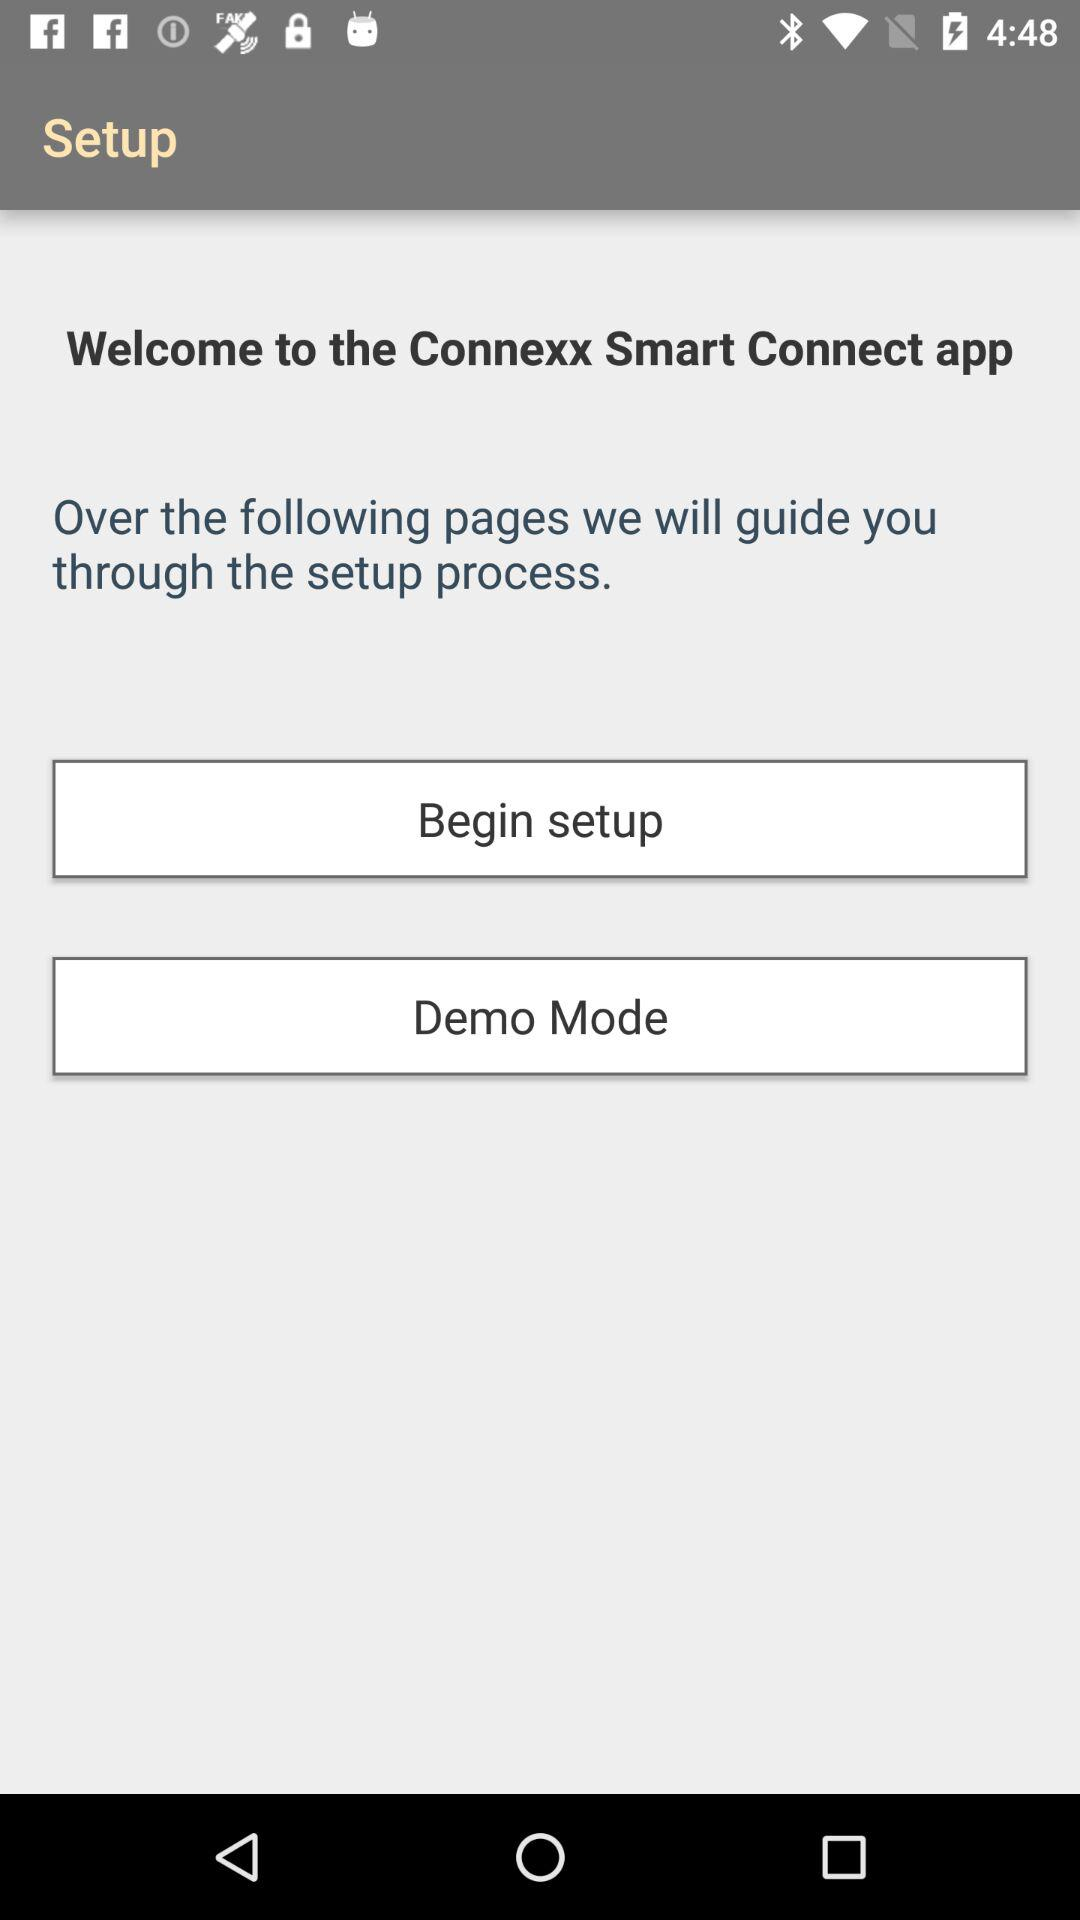What is the name of application? The application name is "Connexx Smart Connect". 